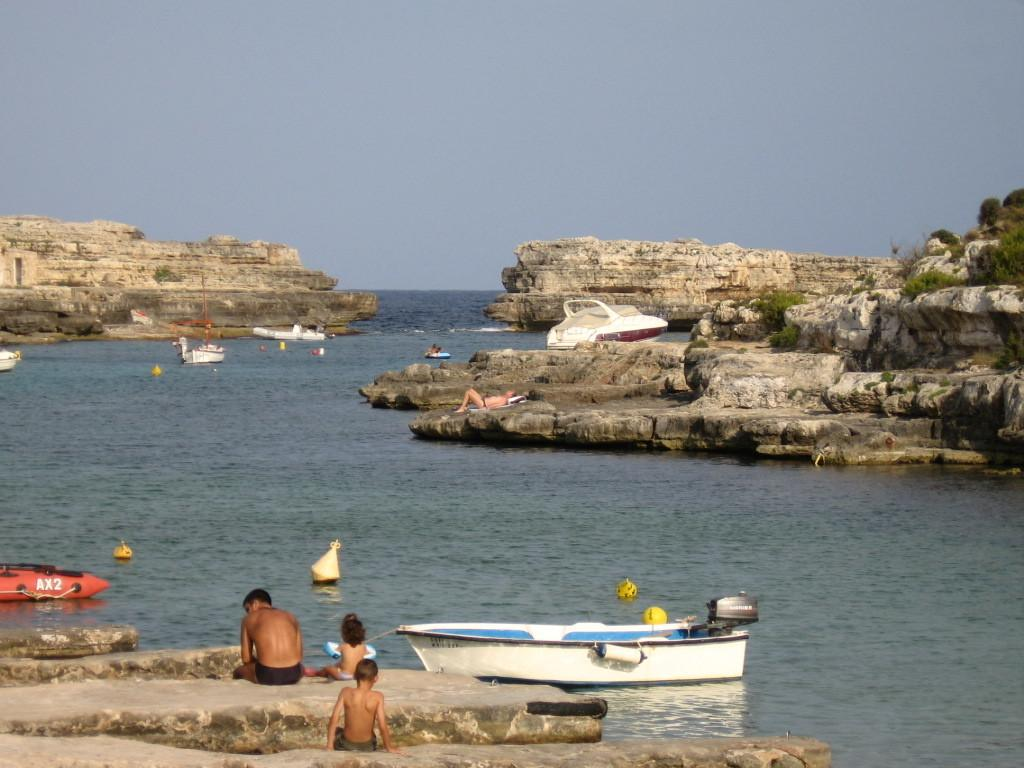What are the people in the image doing on the rocks? The people in the image are sitting and lying on the rocks. What can be seen on the water in the image? Boats and ships are present on the water in the image. What type of vegetation is visible in the image? Trees are present in the image. What is visible above the water and trees in the image? The sky is visible in the image. Is there a ray of light shining on the people sitting on the rocks in the image? There is no mention of a ray of light in the provided facts, so we cannot determine if it is present in the image. Is there a rainstorm happening in the image? There is no mention of a rainstorm in the provided facts, so we cannot determine if it is present in the image. 